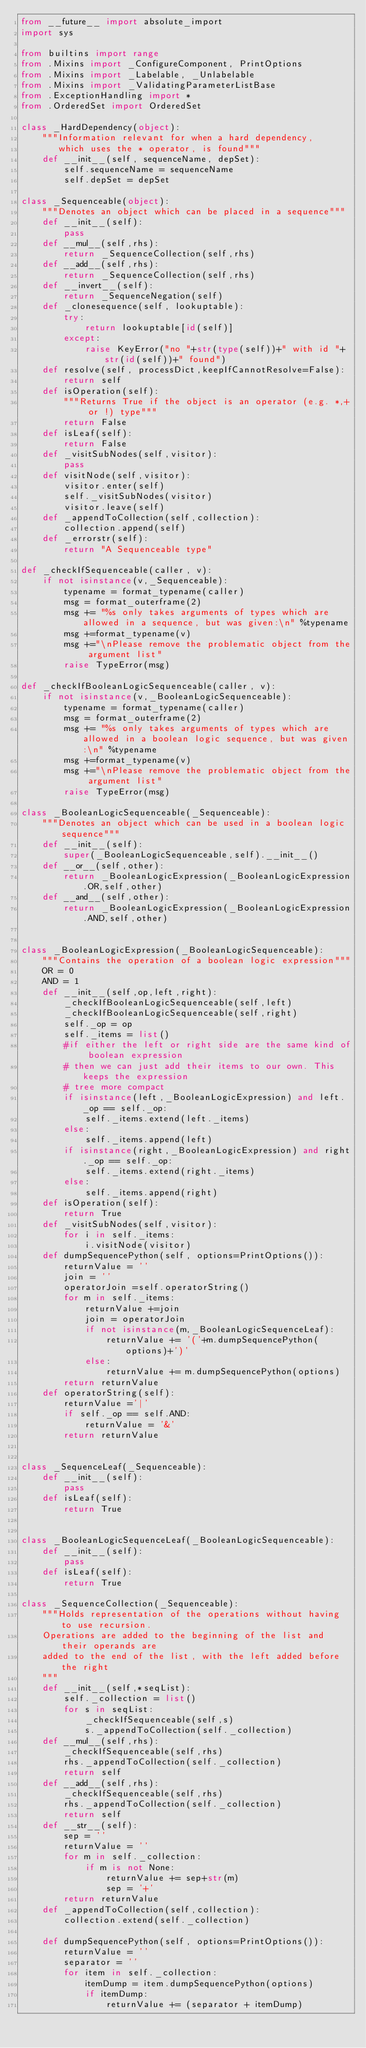<code> <loc_0><loc_0><loc_500><loc_500><_Python_>from __future__ import absolute_import
import sys

from builtins import range
from .Mixins import _ConfigureComponent, PrintOptions
from .Mixins import _Labelable, _Unlabelable
from .Mixins import _ValidatingParameterListBase
from .ExceptionHandling import *
from .OrderedSet import OrderedSet

class _HardDependency(object):
    """Information relevant for when a hard dependency,
       which uses the * operator, is found"""
    def __init__(self, sequenceName, depSet):
        self.sequenceName = sequenceName
        self.depSet = depSet

class _Sequenceable(object):
    """Denotes an object which can be placed in a sequence"""
    def __init__(self):
        pass
    def __mul__(self,rhs):
        return _SequenceCollection(self,rhs)
    def __add__(self,rhs):
        return _SequenceCollection(self,rhs)
    def __invert__(self):
        return _SequenceNegation(self)
    def _clonesequence(self, lookuptable):
        try:
            return lookuptable[id(self)]
        except:
            raise KeyError("no "+str(type(self))+" with id "+str(id(self))+" found")
    def resolve(self, processDict,keepIfCannotResolve=False):
        return self
    def isOperation(self):
        """Returns True if the object is an operator (e.g. *,+ or !) type"""
        return False
    def isLeaf(self):
        return False
    def _visitSubNodes(self,visitor):
        pass
    def visitNode(self,visitor):
        visitor.enter(self)
        self._visitSubNodes(visitor)
        visitor.leave(self)
    def _appendToCollection(self,collection):
        collection.append(self)
    def _errorstr(self):
        return "A Sequenceable type"

def _checkIfSequenceable(caller, v):
    if not isinstance(v,_Sequenceable):
        typename = format_typename(caller)
        msg = format_outerframe(2)
        msg += "%s only takes arguments of types which are allowed in a sequence, but was given:\n" %typename
        msg +=format_typename(v)
        msg +="\nPlease remove the problematic object from the argument list"
        raise TypeError(msg)

def _checkIfBooleanLogicSequenceable(caller, v):
    if not isinstance(v,_BooleanLogicSequenceable):
        typename = format_typename(caller)
        msg = format_outerframe(2)
        msg += "%s only takes arguments of types which are allowed in a boolean logic sequence, but was given:\n" %typename
        msg +=format_typename(v)
        msg +="\nPlease remove the problematic object from the argument list"
        raise TypeError(msg)

class _BooleanLogicSequenceable(_Sequenceable):
    """Denotes an object which can be used in a boolean logic sequence"""
    def __init__(self):
        super(_BooleanLogicSequenceable,self).__init__()
    def __or__(self,other):
        return _BooleanLogicExpression(_BooleanLogicExpression.OR,self,other)
    def __and__(self,other):
        return _BooleanLogicExpression(_BooleanLogicExpression.AND,self,other)


class _BooleanLogicExpression(_BooleanLogicSequenceable):
    """Contains the operation of a boolean logic expression"""
    OR = 0
    AND = 1
    def __init__(self,op,left,right):
        _checkIfBooleanLogicSequenceable(self,left)
        _checkIfBooleanLogicSequenceable(self,right)
        self._op = op
        self._items = list()
        #if either the left or right side are the same kind of boolean expression
        # then we can just add their items to our own. This keeps the expression
        # tree more compact
        if isinstance(left,_BooleanLogicExpression) and left._op == self._op:
            self._items.extend(left._items)
        else:
            self._items.append(left)
        if isinstance(right,_BooleanLogicExpression) and right._op == self._op:
            self._items.extend(right._items)
        else:
            self._items.append(right)
    def isOperation(self):
        return True
    def _visitSubNodes(self,visitor):
        for i in self._items:
            i.visitNode(visitor)
    def dumpSequencePython(self, options=PrintOptions()):
        returnValue = ''
        join = ''
        operatorJoin =self.operatorString()
        for m in self._items:
            returnValue +=join
            join = operatorJoin
            if not isinstance(m,_BooleanLogicSequenceLeaf):
                returnValue += '('+m.dumpSequencePython(options)+')'
            else:
                returnValue += m.dumpSequencePython(options)
        return returnValue
    def operatorString(self):
        returnValue ='|'
        if self._op == self.AND:
            returnValue = '&'
        return returnValue


class _SequenceLeaf(_Sequenceable):
    def __init__(self):
        pass
    def isLeaf(self):
        return True


class _BooleanLogicSequenceLeaf(_BooleanLogicSequenceable):
    def __init__(self):
        pass
    def isLeaf(self):
        return True

class _SequenceCollection(_Sequenceable):
    """Holds representation of the operations without having to use recursion.
    Operations are added to the beginning of the list and their operands are
    added to the end of the list, with the left added before the right
    """
    def __init__(self,*seqList):
        self._collection = list()
        for s in seqList:
            _checkIfSequenceable(self,s)
            s._appendToCollection(self._collection)
    def __mul__(self,rhs):
        _checkIfSequenceable(self,rhs)
        rhs._appendToCollection(self._collection)
        return self
    def __add__(self,rhs):
        _checkIfSequenceable(self,rhs)
        rhs._appendToCollection(self._collection)
        return self
    def __str__(self):
        sep = ''
        returnValue = ''
        for m in self._collection:
            if m is not None:
                returnValue += sep+str(m)
                sep = '+'
        return returnValue
    def _appendToCollection(self,collection):
        collection.extend(self._collection)

    def dumpSequencePython(self, options=PrintOptions()):
        returnValue = ''
        separator = ''
        for item in self._collection:
            itemDump = item.dumpSequencePython(options)
            if itemDump:
                returnValue += (separator + itemDump)</code> 